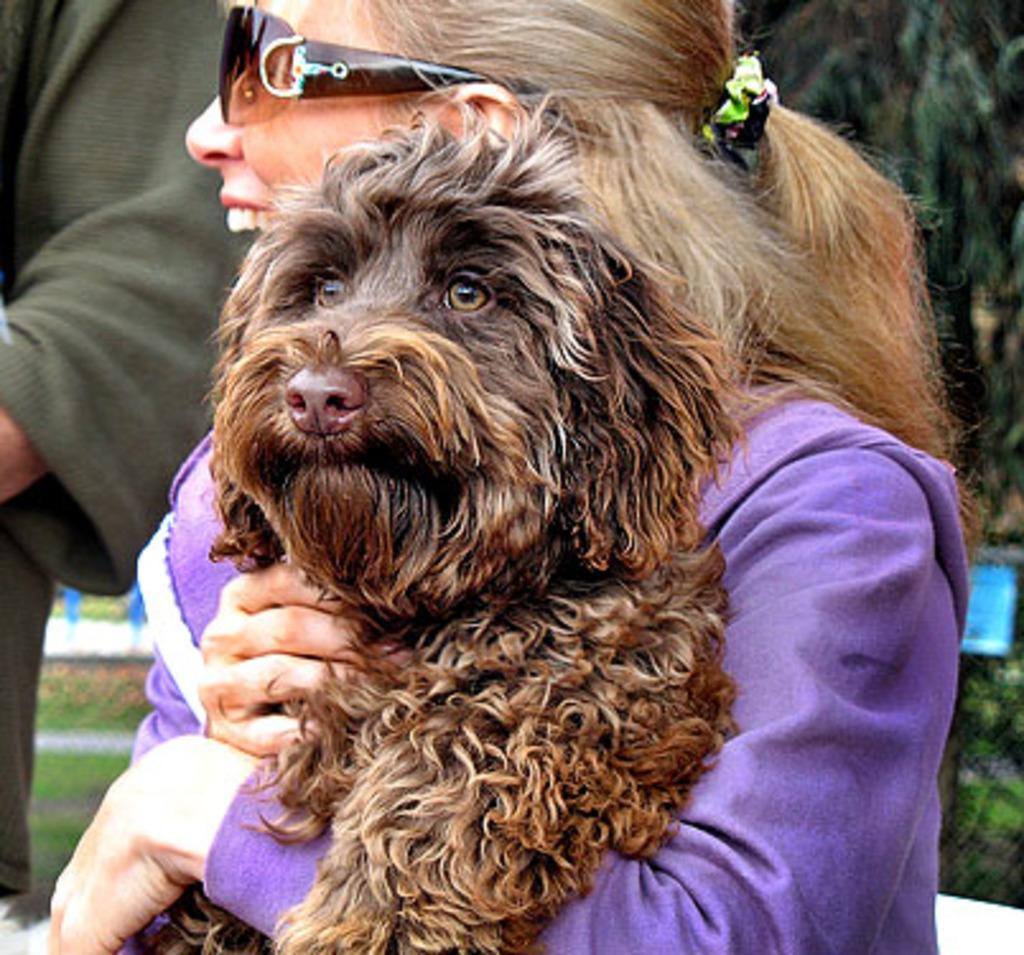What is the main subject of the image? There is a lady person in the image. What is the lady person wearing? The lady person is wearing a violet color dress. What is the lady person holding in her hands? The lady person is holding a dog in her hands. What type of grip does the lady person have on the pan in the image? There is no pan present in the image, and the lady person is holding a dog, not a pan. 